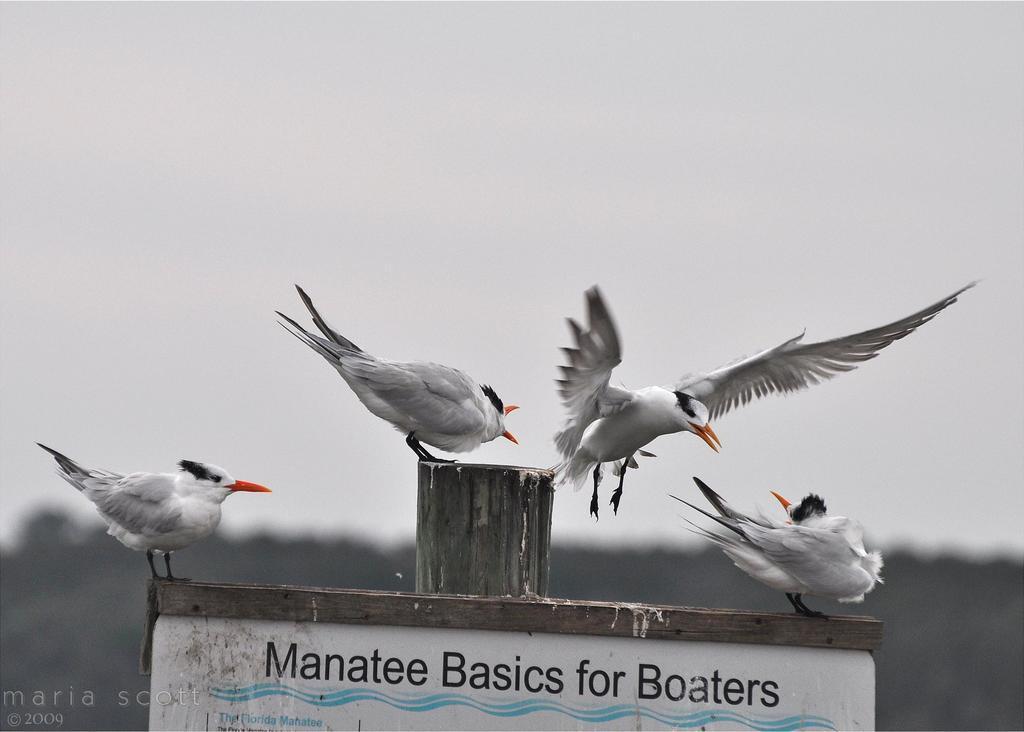Could you give a brief overview of what you see in this image? In this image I can see four birds which are in white, black and an orange color. I can see the board and the wooden pole. In the background I can see the trees and the sky. 